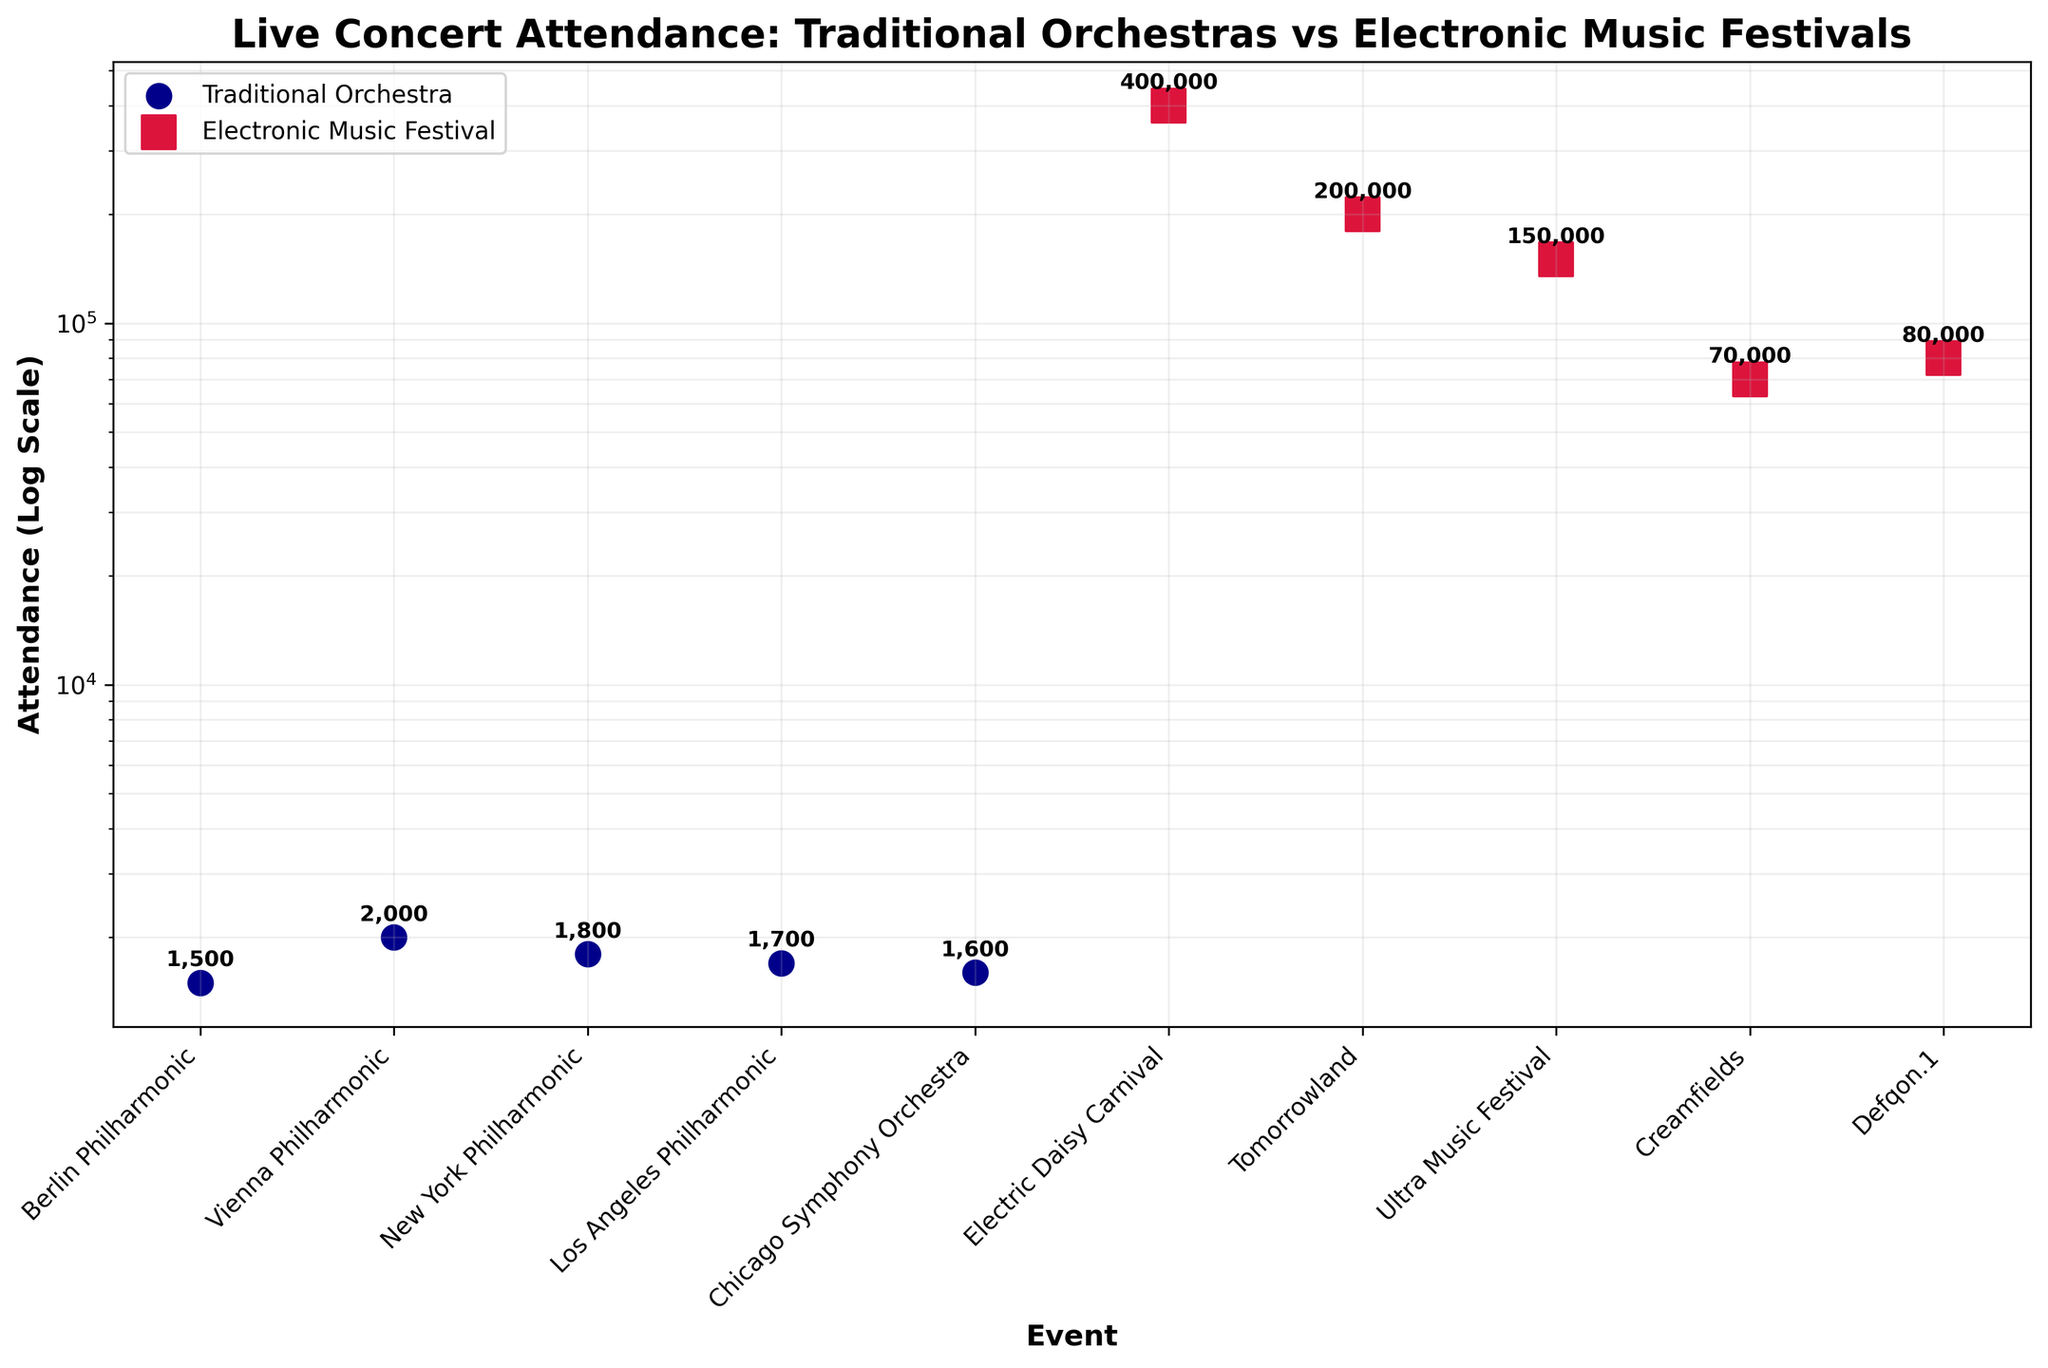What type of events are being compared in the scatter plot? The title of the scatter plot is "Live Concert Attendance: Traditional Orchestras vs Electronic Music Festivals", which indicates that traditional orchestras and electronic music festivals are being compared.
Answer: Traditional Orchestras and Electronic Music Festivals Which event has the highest attendance? The data points for attendance show that "Electric Daisy Carnival" has the highest attendance with 400,000 attendees, as annotated on the scatter plot.
Answer: Electric Daisy Carnival How does the attendance of the highest traditional orchestra event compare to the lowest electronic music festival event? The highest attended traditional orchestra event is "Vienna Philharmonic" with 2,000 attendees, and the lowest attended electronic music festival is "Creamfields" with 70,000 attendees. Comparing these numbers shows a vast difference.
Answer: 2,000 vs 70,000 What is the average attendance of the electronic music festivals shown in the plot? Sum the attendance of all electronic music festivals (400,000 + 200,000 + 150,000 + 70,000 + 80,000) which equals 900,000, and then divide by the number of events (5), giving an average attendance.
Answer: 180,000 Which type of event generally has a lower attendance based on the scatter plot? By observing the log scale on the y-axis, traditional orchestras have a lower attendance range between 1,500 to 2,000, whereas electronic music festivals range from 70,000 to 400,000.
Answer: Traditional Orchestras Which electronic music festival has the lowest attendance, and how does it compare to the highest attended traditional orchestra? "Creamfields" is the electronic music festival with the lowest attendance at 70,000, which is significantly higher compared to the highest traditional orchestra, "Vienna Philharmonic," at 2,000 attendees.
Answer: Creamfields (70,000) vs Vienna Philharmonic (2,000) What is the range of attendance for traditional orchestra events? The attendance range for traditional orchestras can be identified by noting the highest and lowest values - the highest is 2,000 (Vienna Philharmonic) and the lowest is 1,500 (Berlin Philharmonic). So, the range is 2,000 - 1,500.
Answer: 500 What can you infer about the popularity of traditional orchestras versus electronic music festivals based on the attendance data? Electronic music festivals consistently have higher attendance numbers in the range of 70,000 to 400,000, compared to traditional orchestras which range from 1,500 to 2,000, suggesting that electronic festivals are more popular in terms of attendance.
Answer: Electronic music festivals are more popular How does the scatter plot, with y-axis being on a log scale, help in understanding the differences in attendance? Using a log scale for the y-axis helps display wide ranges of attendance data more clearly, making it easier to compare both low and high values within the same plot by scaling the data non-linearly.
Answer: Clarity in wide range differences 